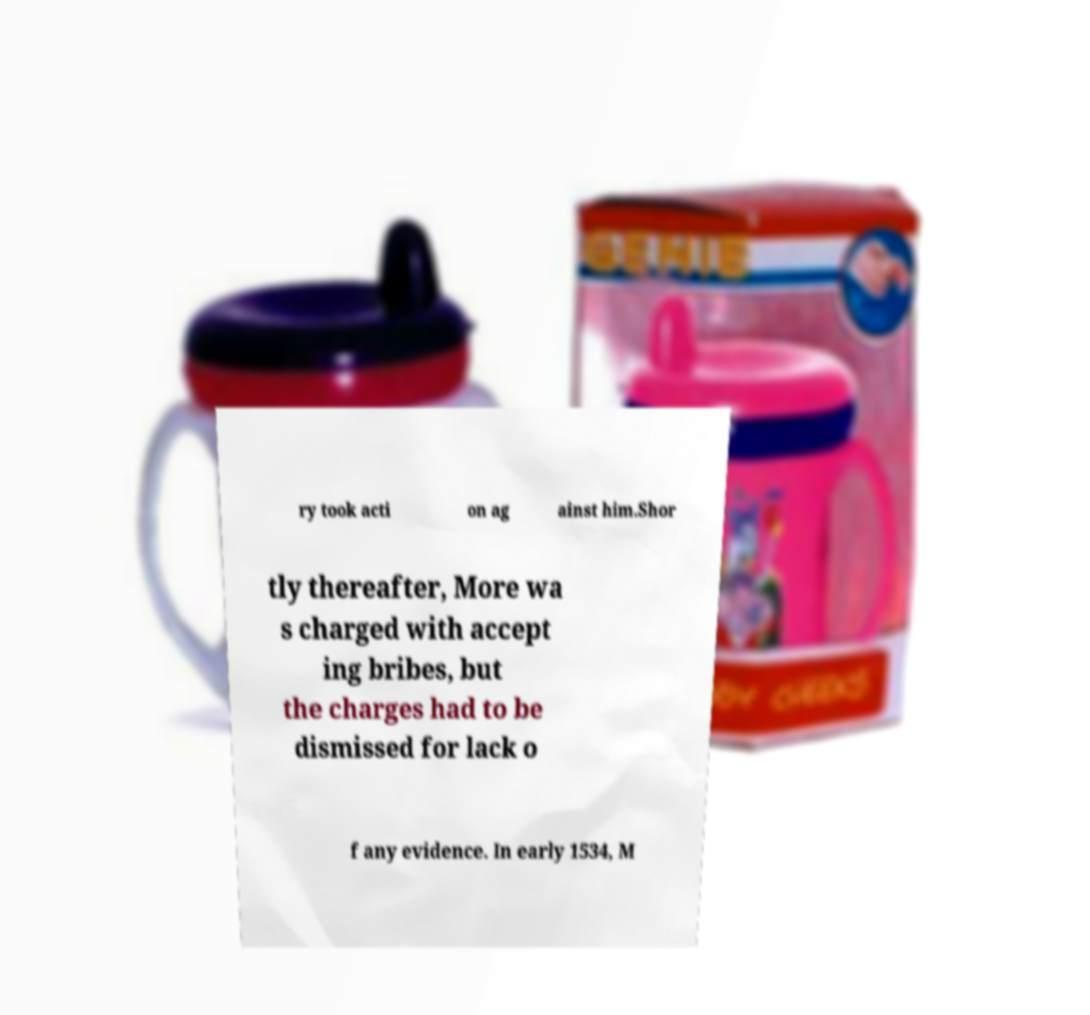What messages or text are displayed in this image? I need them in a readable, typed format. ry took acti on ag ainst him.Shor tly thereafter, More wa s charged with accept ing bribes, but the charges had to be dismissed for lack o f any evidence. In early 1534, M 